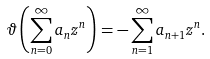Convert formula to latex. <formula><loc_0><loc_0><loc_500><loc_500>\vartheta \left ( \sum _ { n = 0 } ^ { \infty } a _ { n } z ^ { n } \right ) = - \sum _ { n = 1 } ^ { \infty } a _ { n + 1 } z ^ { n } .</formula> 